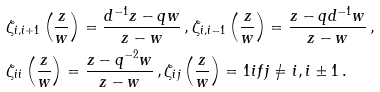Convert formula to latex. <formula><loc_0><loc_0><loc_500><loc_500>& \zeta _ { i , i + 1 } \left ( \frac { z } { w } \right ) = \frac { d ^ { - 1 } z - q w } { z - w } \, , \zeta _ { i , i - 1 } \left ( \frac { z } { w } \right ) = \frac { z - q d ^ { - 1 } w } { z - w } \, , \\ & \zeta _ { i i } \left ( \frac { z } { w } \right ) = \frac { z - q ^ { - 2 } w } { z - w } \, , \zeta _ { i j } \left ( \frac { z } { w } \right ) = 1 i f j \ne i , i \pm 1 \, .</formula> 